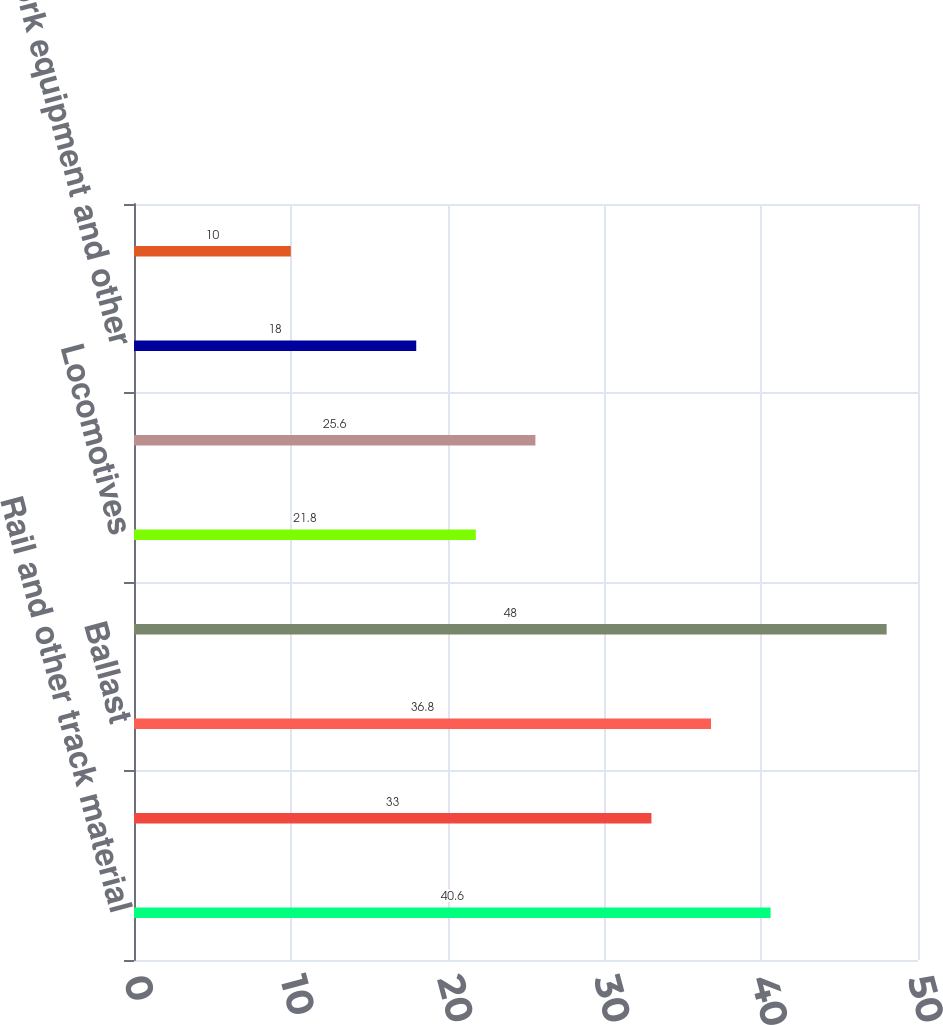Convert chart to OTSL. <chart><loc_0><loc_0><loc_500><loc_500><bar_chart><fcel>Rail and other track material<fcel>Ties<fcel>Ballast<fcel>Other roadway a<fcel>Locomotives<fcel>Freight cars<fcel>Work equipment and other<fcel>Technology and other<nl><fcel>40.6<fcel>33<fcel>36.8<fcel>48<fcel>21.8<fcel>25.6<fcel>18<fcel>10<nl></chart> 